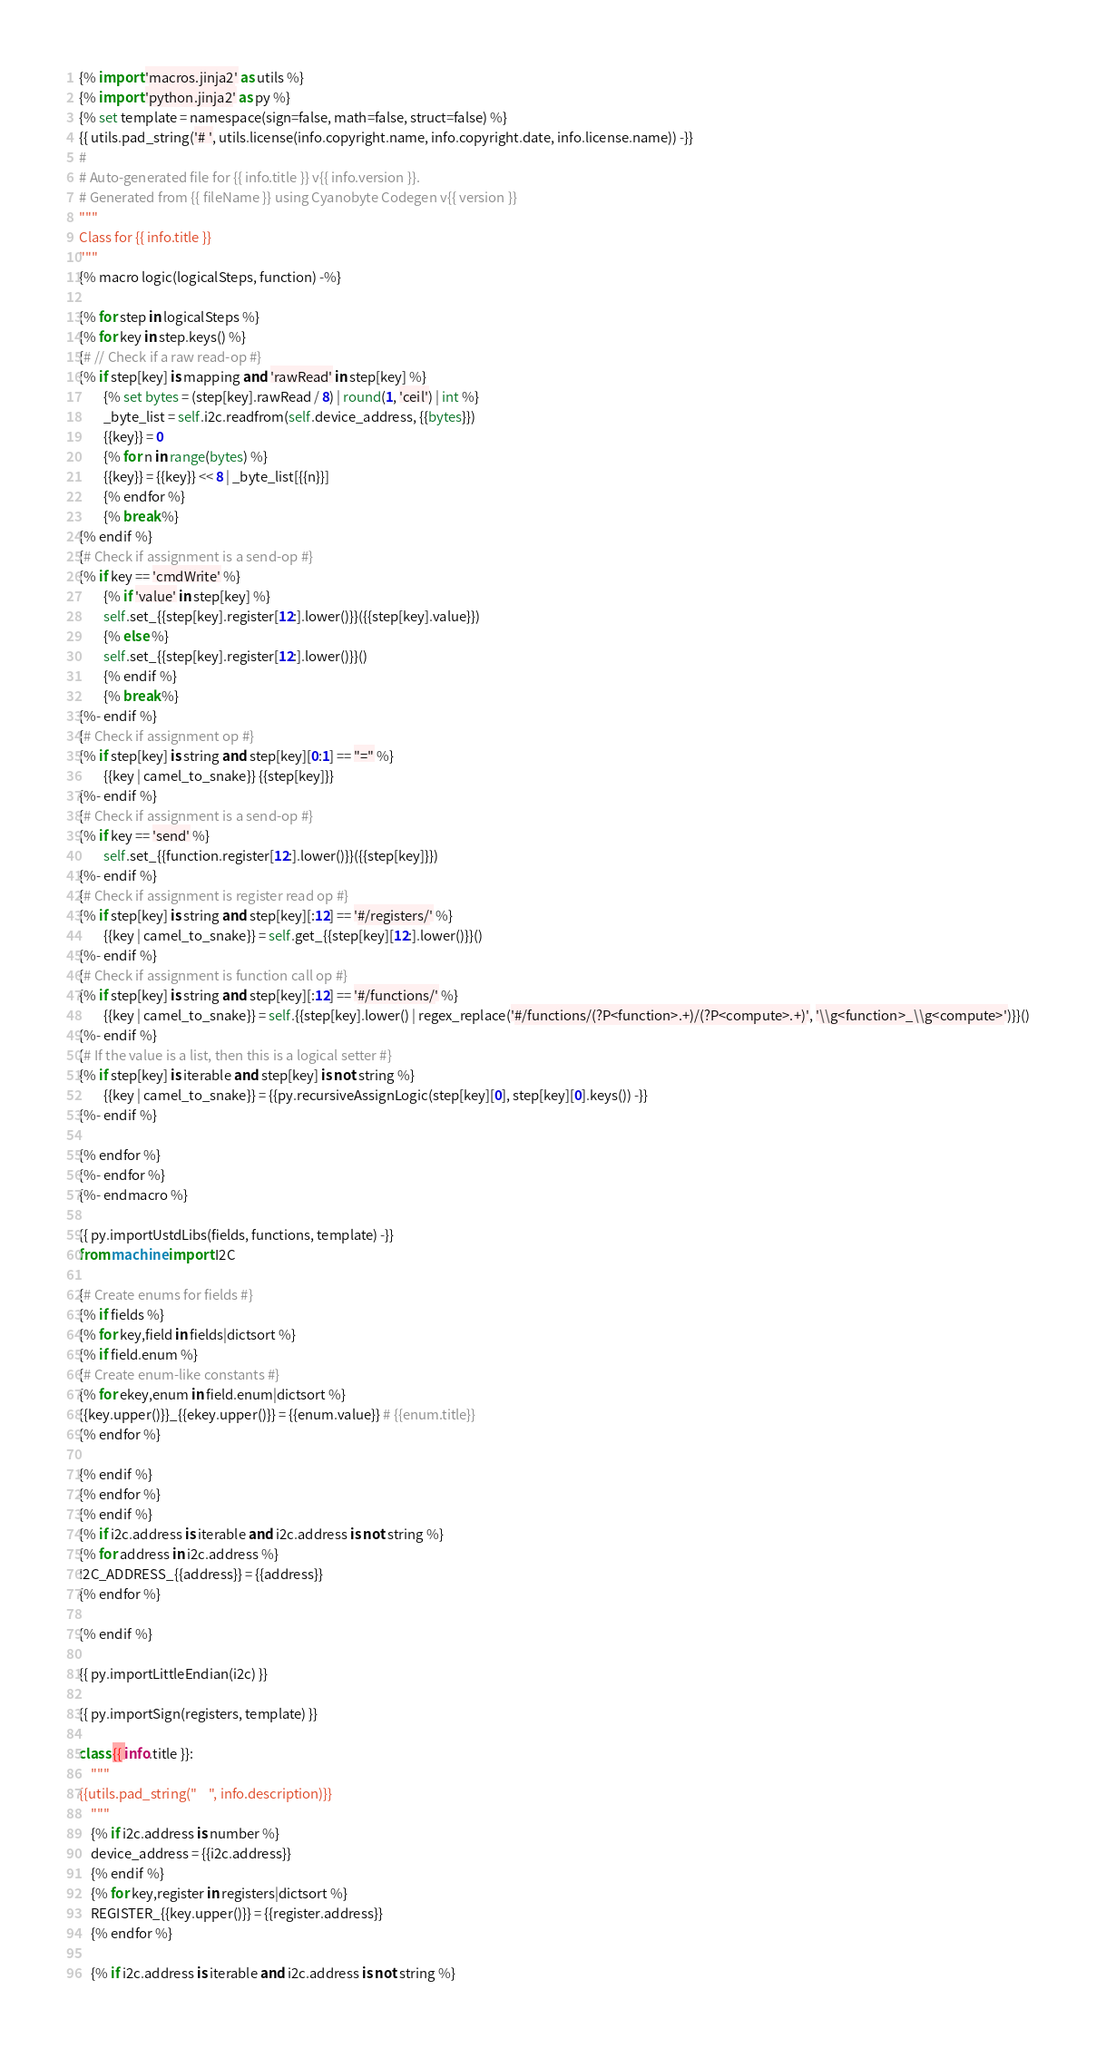<code> <loc_0><loc_0><loc_500><loc_500><_Python_>{% import 'macros.jinja2' as utils %}
{% import 'python.jinja2' as py %}
{% set template = namespace(sign=false, math=false, struct=false) %}
{{ utils.pad_string('# ', utils.license(info.copyright.name, info.copyright.date, info.license.name)) -}}
#
# Auto-generated file for {{ info.title }} v{{ info.version }}.
# Generated from {{ fileName }} using Cyanobyte Codegen v{{ version }}
"""
Class for {{ info.title }}
"""
{% macro logic(logicalSteps, function) -%}

{% for step in logicalSteps %}
{% for key in step.keys() %}
{# // Check if a raw read-op #}
{% if step[key] is mapping and 'rawRead' in step[key] %}
        {% set bytes = (step[key].rawRead / 8) | round(1, 'ceil') | int %}
        _byte_list = self.i2c.readfrom(self.device_address, {{bytes}})
        {{key}} = 0
        {% for n in range(bytes) %}
        {{key}} = {{key}} << 8 | _byte_list[{{n}}]
        {% endfor %}
        {% break %}
{% endif %}
{# Check if assignment is a send-op #}
{% if key == 'cmdWrite' %}
        {% if 'value' in step[key] %}
        self.set_{{step[key].register[12:].lower()}}({{step[key].value}})
        {% else %}
        self.set_{{step[key].register[12:].lower()}}()
        {% endif %}
        {% break %}
{%- endif %}
{# Check if assignment op #}
{% if step[key] is string and step[key][0:1] == "=" %}
        {{key | camel_to_snake}} {{step[key]}}
{%- endif %}
{# Check if assignment is a send-op #}
{% if key == 'send' %}
        self.set_{{function.register[12:].lower()}}({{step[key]}})
{%- endif %}
{# Check if assignment is register read op #}
{% if step[key] is string and step[key][:12] == '#/registers/' %}
        {{key | camel_to_snake}} = self.get_{{step[key][12:].lower()}}()
{%- endif %}
{# Check if assignment is function call op #}
{% if step[key] is string and step[key][:12] == '#/functions/' %}
        {{key | camel_to_snake}} = self.{{step[key].lower() | regex_replace('#/functions/(?P<function>.+)/(?P<compute>.+)', '\\g<function>_\\g<compute>')}}()
{%- endif %}
{# If the value is a list, then this is a logical setter #}
{% if step[key] is iterable and step[key] is not string %}
        {{key | camel_to_snake}} = {{py.recursiveAssignLogic(step[key][0], step[key][0].keys()) -}}
{%- endif %}

{% endfor %}
{%- endfor %}
{%- endmacro %}

{{ py.importUstdLibs(fields, functions, template) -}}
from machine import I2C

{# Create enums for fields #}
{% if fields %}
{% for key,field in fields|dictsort %}
{% if field.enum %}
{# Create enum-like constants #}
{% for ekey,enum in field.enum|dictsort %}
{{key.upper()}}_{{ekey.upper()}} = {{enum.value}} # {{enum.title}}
{% endfor %}

{% endif %}
{% endfor %}
{% endif %}
{% if i2c.address is iterable and i2c.address is not string %}
{% for address in i2c.address %}
I2C_ADDRESS_{{address}} = {{address}}
{% endfor %}

{% endif %}

{{ py.importLittleEndian(i2c) }}

{{ py.importSign(registers, template) }}

class {{ info.title }}:
    """
{{utils.pad_string("    ", info.description)}}
    """
    {% if i2c.address is number %}
    device_address = {{i2c.address}}
    {% endif %}
    {% for key,register in registers|dictsort %}
    REGISTER_{{key.upper()}} = {{register.address}}
    {% endfor %}

    {% if i2c.address is iterable and i2c.address is not string %}</code> 